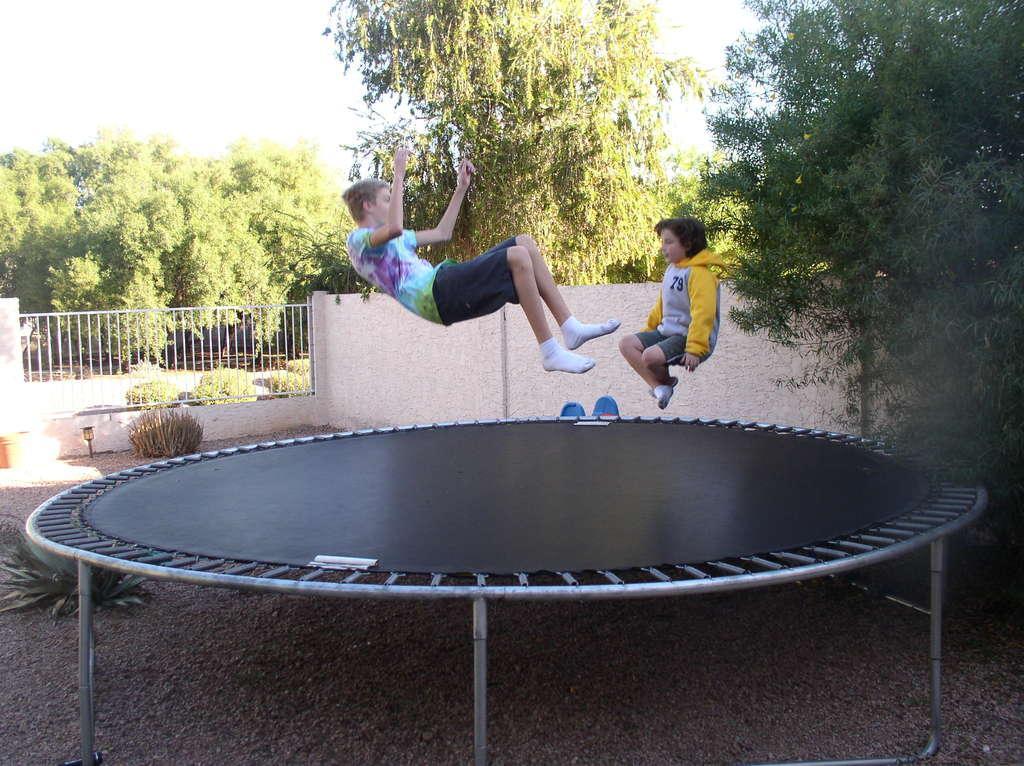Can you describe this image briefly? This image is taken outdoors. At the bottom of the image there is a ground. In the middle of the image there is a trampoline and two kids are playing on the trampoline. At the top of the image there is a sky. In the background there are many trees and plants and there is a wall with a railing. 